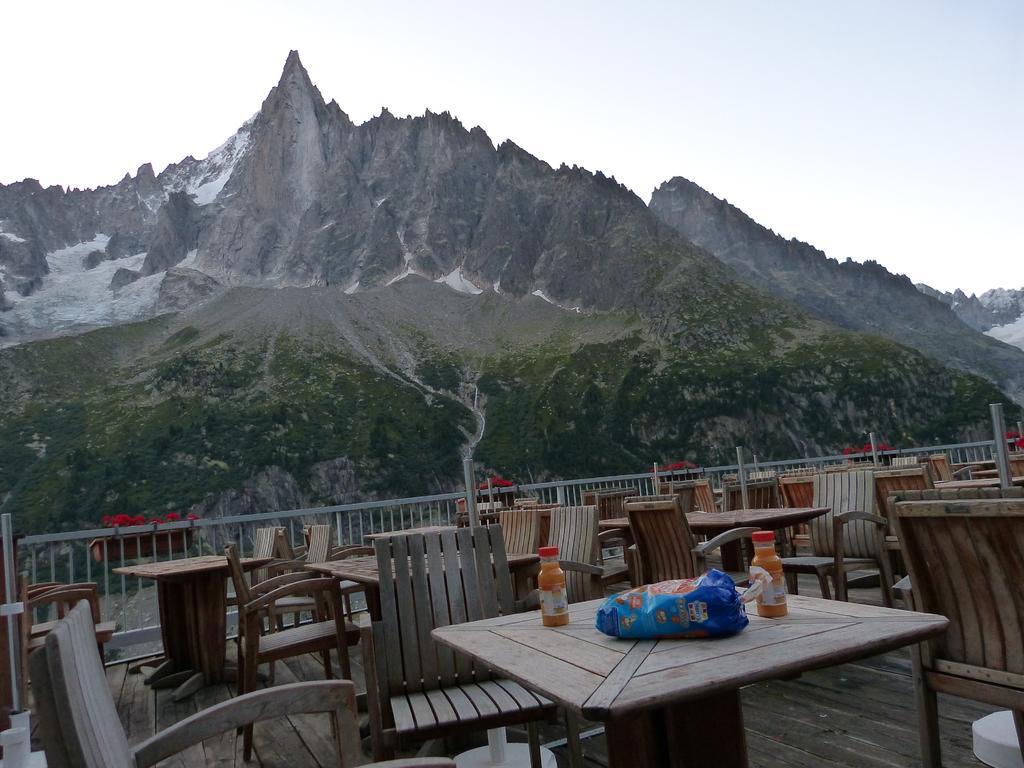How would you summarize this image in a sentence or two? In the image in the center, we can see tables, chairs and fence. On the table, we can see bottles and plastic packet. In the background we can see the sky, clouds and hills. 